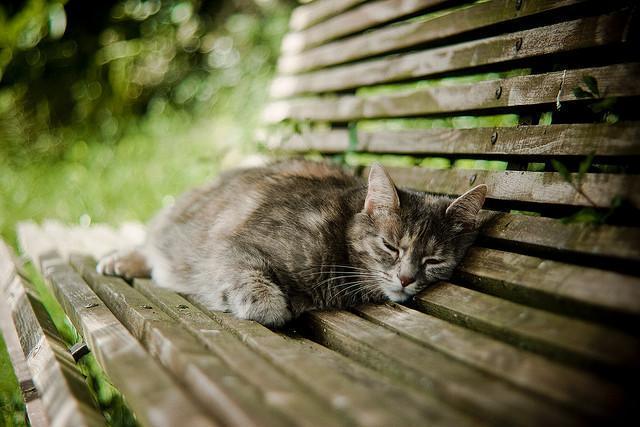How many benches are visible?
Give a very brief answer. 1. How many people are shown?
Give a very brief answer. 0. 